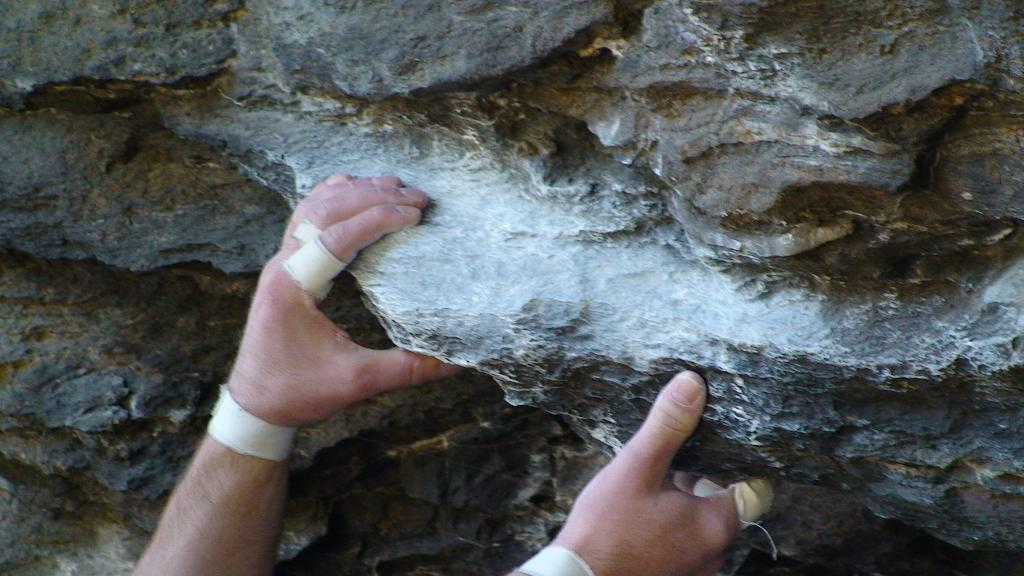What body part is visible in the image? There are a person's hands in the image. What object is present in the image alongside the hands? There is a rock in the image. What type of collar can be seen on the rock in the image? There is no collar present on the rock in the image, as rocks do not have collars. How many apples are visible on the person's hands in the image? There are no apples visible on the person's hands in the image. 